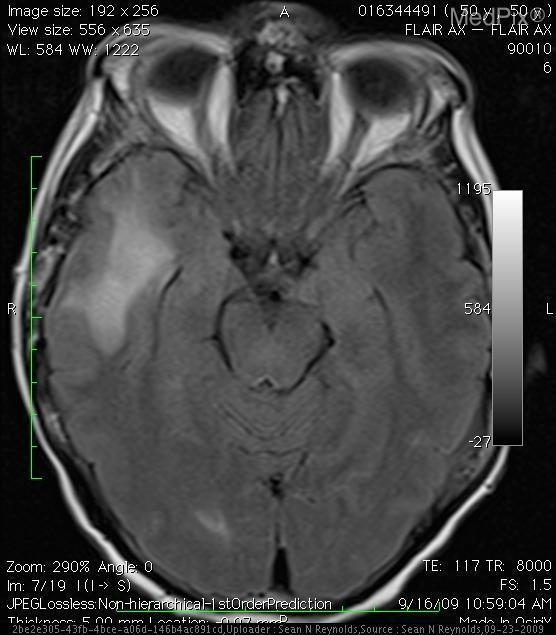Are structures associated with the midbrain located in this image?
Give a very brief answer. Yes. Is the midbrain identified in this section?
Answer briefly. Yes. What structures is identified in the middle of this image?
Quick response, please. Pons. Is this an image of the right and left temporal lobes?
Write a very short answer. Yes. Is the grey/white matter border well differentiated?
Write a very short answer. Yes. Are brain structures shifted across the midline?
Quick response, please. No. Is there a midline shift of the cerebral parenchyma?
Short answer required. No. Is this a transverse section?
Be succinct. Yes. Is this a t2 weighted image?
Concise answer only. Yes. 